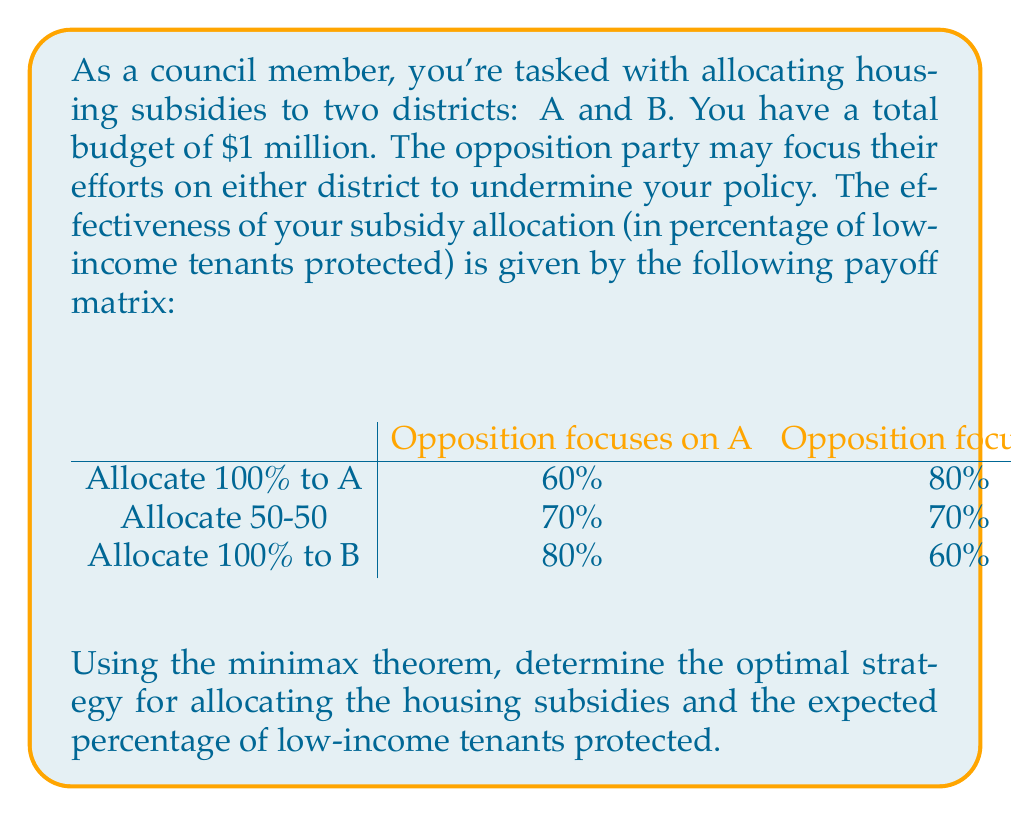Can you answer this question? To solve this problem using the minimax theorem, we'll follow these steps:

1) First, we need to identify the saddle point, if one exists. A saddle point occurs when the minimum of a row's maximum values equals the maximum of a column's minimum values.

Row maxima: max(60%, 80%) = 80%, max(70%, 70%) = 70%, max(80%, 60%) = 80%
Row minimum: min(80%, 70%, 80%) = 70%

Column minima: min(60%, 70%, 80%) = 60%, min(80%, 70%, 60%) = 60%
Column maximum: max(60%, 60%) = 60%

Since the row minimum (70%) doesn't equal the column maximum (60%), there's no saddle point. We need to find a mixed strategy.

2) Let's define our variables:
   $x$: probability of allocating 100% to A
   $y$: probability of allocating 50-50
   $z$: probability of allocating 100% to B

3) We want to maximize the minimum expected payoff. Let $v$ be this value. We can set up the following inequalities:

   $60x + 70y + 80z \geq v$
   $80x + 70y + 60z \geq v$
   $x + y + z = 1$
   $x, y, z \geq 0$

4) We want to maximize $v$ subject to these constraints. This is a linear programming problem, which can be solved using the simplex method or other LP solvers.

5) Solving this LP problem (which is beyond the scope of this explanation), we get:
   $x = 0.25$, $y = 0.5$, $z = 0.25$, and $v = 70$

6) This means the optimal strategy is:
   - Allocate 100% to A with 25% probability
   - Allocate 50-50 with 50% probability
   - Allocate 100% to B with 25% probability

7) The expected percentage of low-income tenants protected is 70%.
Answer: The optimal strategy is to allocate 100% to A with 25% probability, allocate 50-50 with 50% probability, and allocate 100% to B with 25% probability. The expected percentage of low-income tenants protected is 70%. 